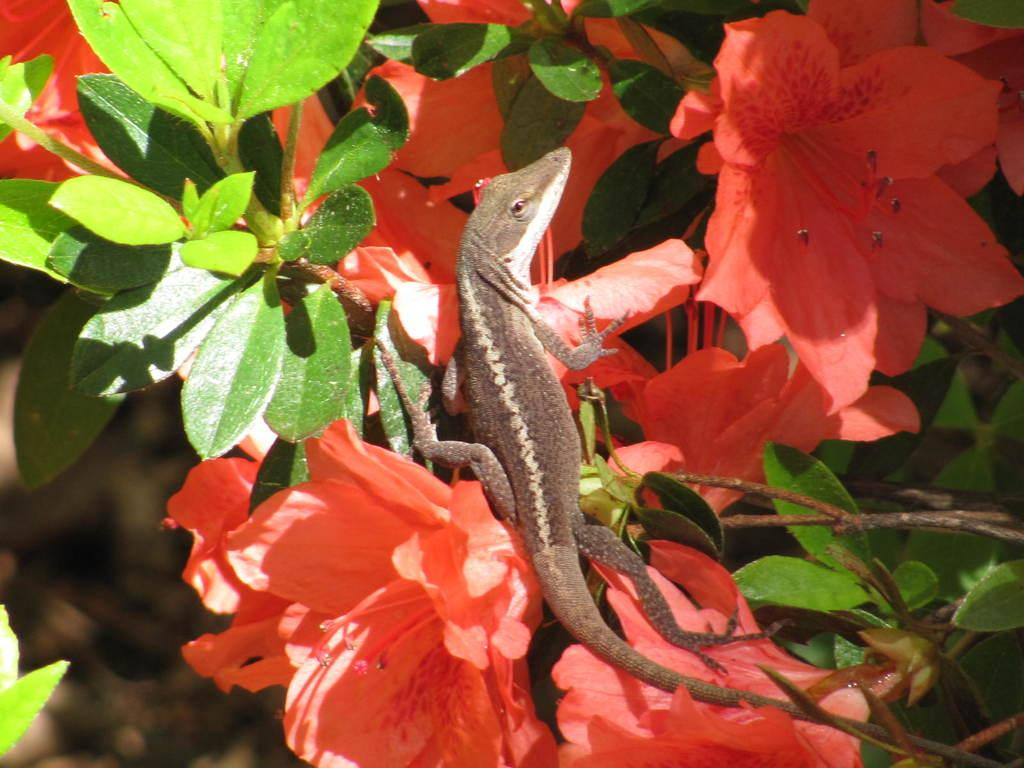What is the main subject in the foreground of the image? There is a lizard in the foreground of the image. What is the lizard positioned on? The lizard is on flowering plants. Can you describe the possible setting of the image? The image may have been taken in a garden. What type of egg is the lizard sitting on in the image? There is no egg present in the image; the lizard is on flowering plants. Who is the manager of the lizard in the image? There is no manager mentioned or implied in the image; it is a photograph of a lizard on flowering plants. 